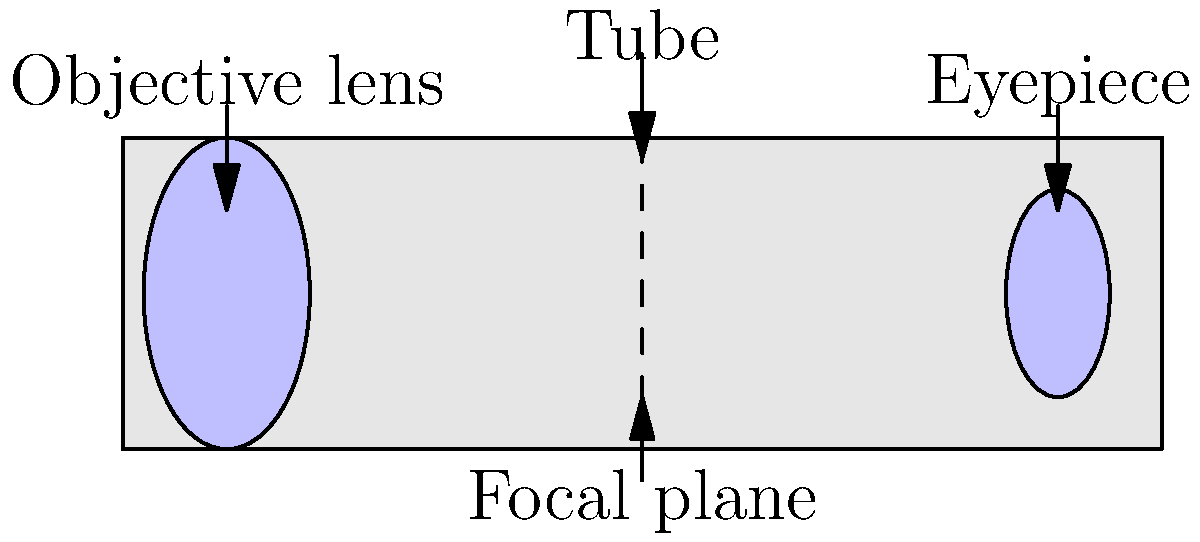In a refracting telescope, what is the primary function of the objective lens, and how does it relate to the focal plane shown in the diagram? To understand the function of the objective lens in a refracting telescope, let's break it down step-by-step:

1. The objective lens is the large lens at the front of the telescope (left side in the diagram).

2. Its primary function is to gather light from distant objects and focus it to form an image.

3. The light rays from a distant object are essentially parallel when they reach the telescope.

4. As the light passes through the objective lens, it is refracted (bent) and converges to a point.

5. This point of convergence is called the focal point, and it lies on the focal plane (shown as a dashed line in the diagram).

6. The distance from the objective lens to the focal plane is called the focal length.

7. The larger the objective lens, the more light it can gather, allowing for viewing of fainter objects.

8. The focal plane is where the real image of the distant object is formed.

9. This image is then magnified by the eyepiece lens for viewing.

In the context of web development and open-source projects, understanding the principles of optics and how different components work together in a system like a telescope can be analogous to understanding how different modules or components interact in a web application, particularly in frameworks like Polymer.
Answer: The objective lens gathers and focuses light to form an image at the focal plane. 